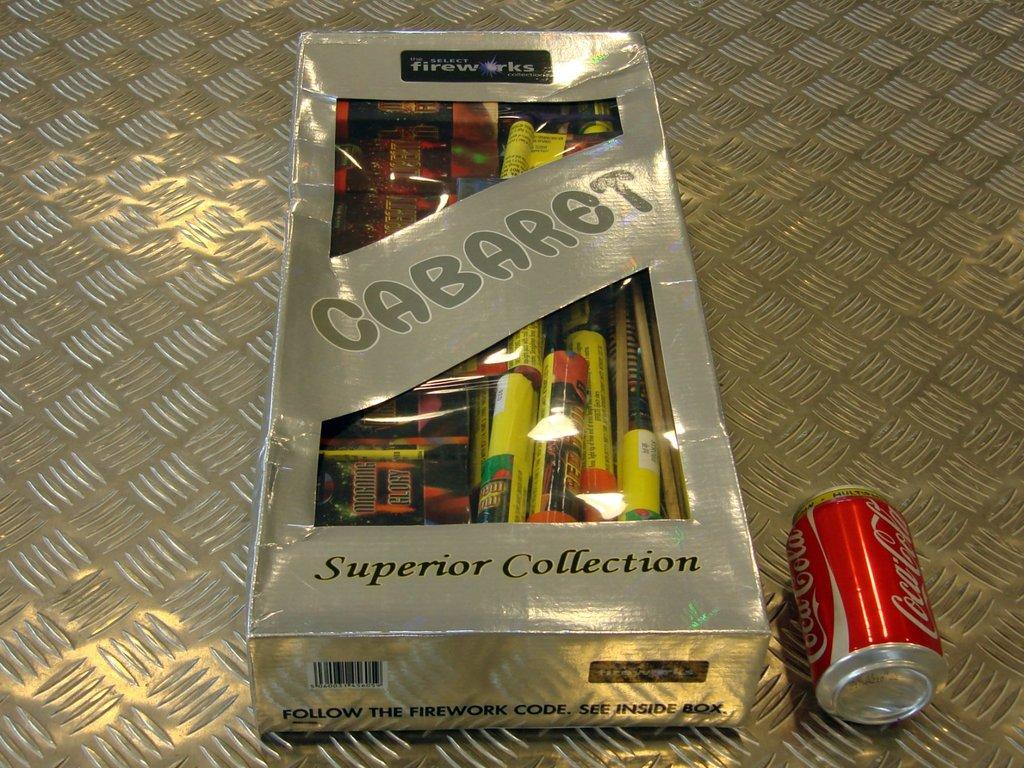What is the red soda can brand?
Offer a very short reply. Coca cola. What is inside the big wrapped box?
Your answer should be very brief. Fireworks. 